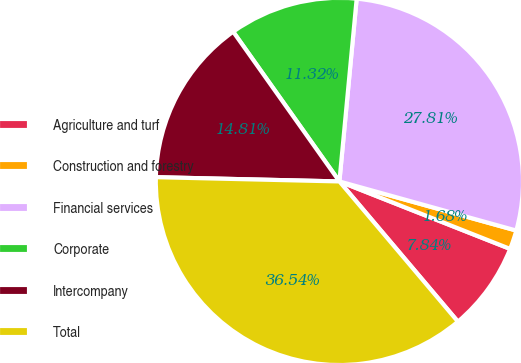<chart> <loc_0><loc_0><loc_500><loc_500><pie_chart><fcel>Agriculture and turf<fcel>Construction and forestry<fcel>Financial services<fcel>Corporate<fcel>Intercompany<fcel>Total<nl><fcel>7.84%<fcel>1.68%<fcel>27.81%<fcel>11.32%<fcel>14.81%<fcel>36.54%<nl></chart> 